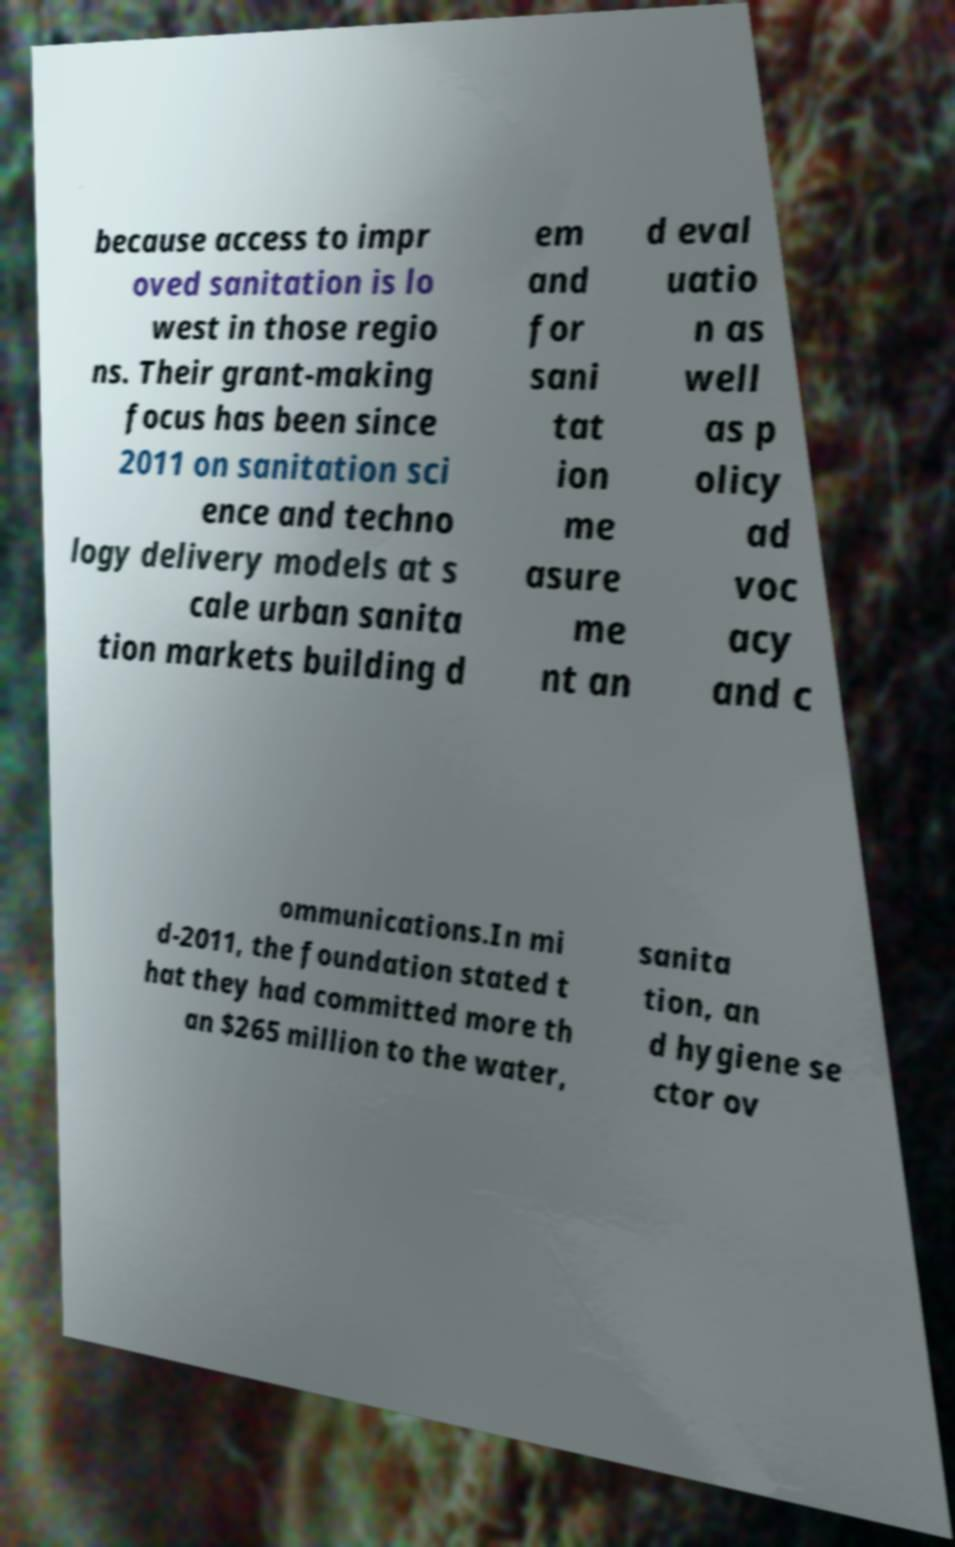There's text embedded in this image that I need extracted. Can you transcribe it verbatim? because access to impr oved sanitation is lo west in those regio ns. Their grant-making focus has been since 2011 on sanitation sci ence and techno logy delivery models at s cale urban sanita tion markets building d em and for sani tat ion me asure me nt an d eval uatio n as well as p olicy ad voc acy and c ommunications.In mi d-2011, the foundation stated t hat they had committed more th an $265 million to the water, sanita tion, an d hygiene se ctor ov 